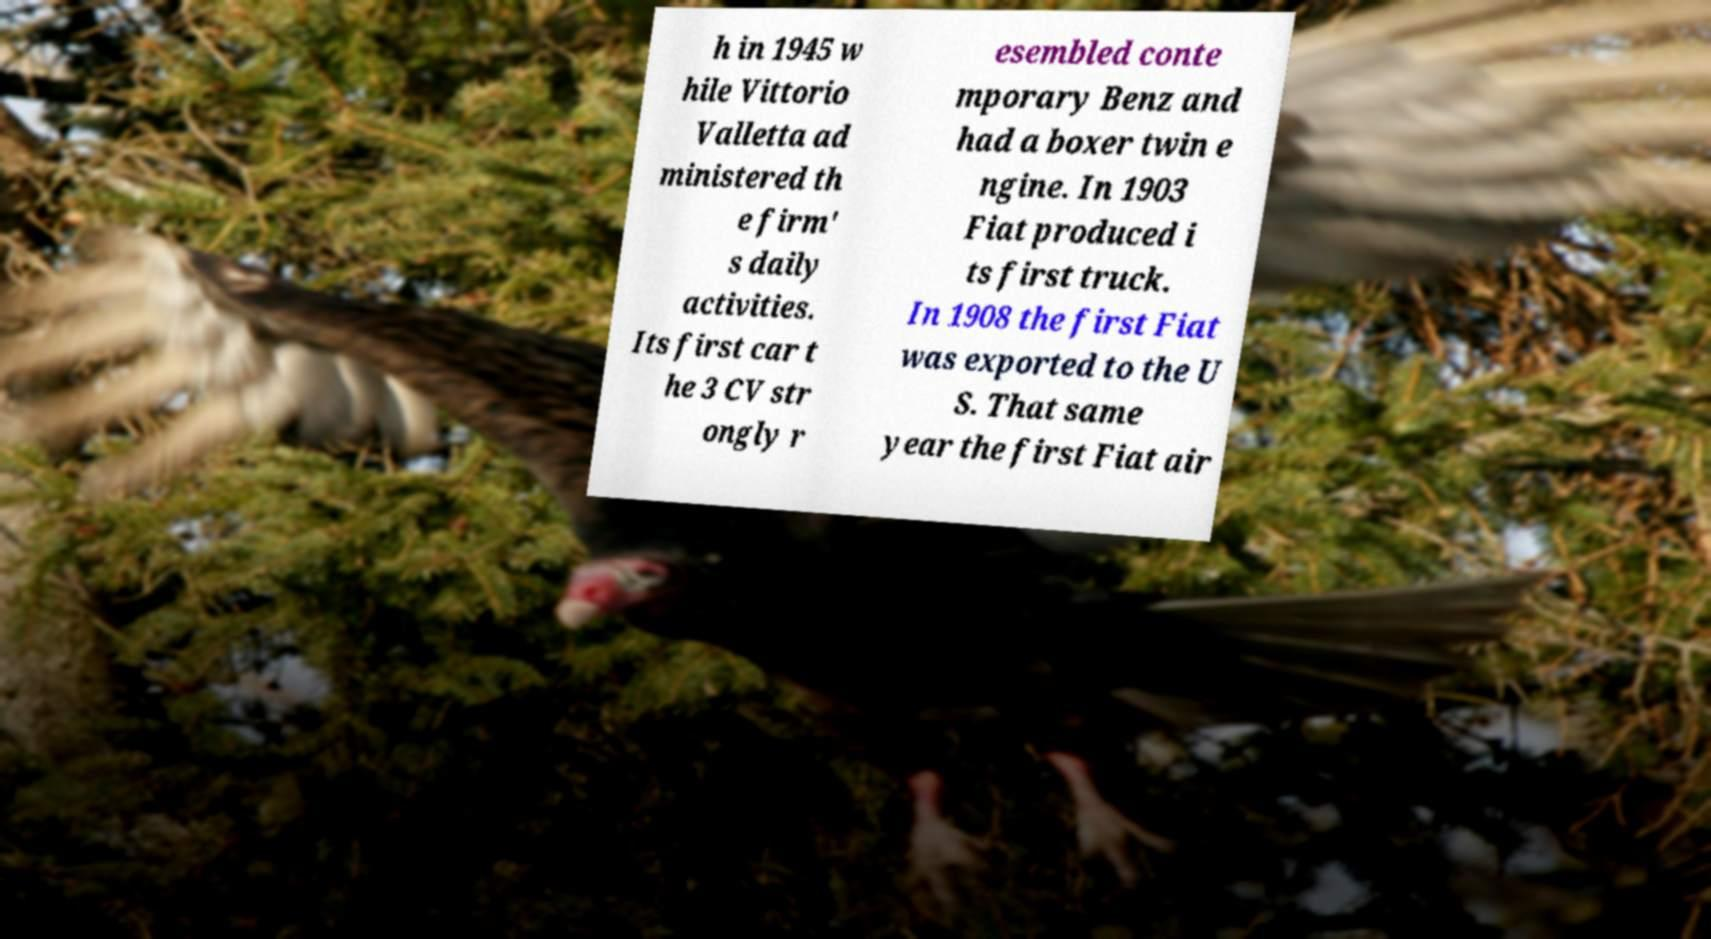I need the written content from this picture converted into text. Can you do that? h in 1945 w hile Vittorio Valletta ad ministered th e firm' s daily activities. Its first car t he 3 CV str ongly r esembled conte mporary Benz and had a boxer twin e ngine. In 1903 Fiat produced i ts first truck. In 1908 the first Fiat was exported to the U S. That same year the first Fiat air 